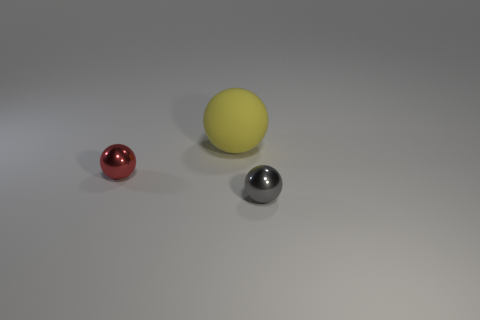There is a shiny ball that is in front of the red shiny ball; are there any spheres in front of it? Yes, there is a silver-colored sphere located in front of the red sphere. The image shows two shiny spheres, with the red one positioned behind the silver one from the perspective of the viewer. 